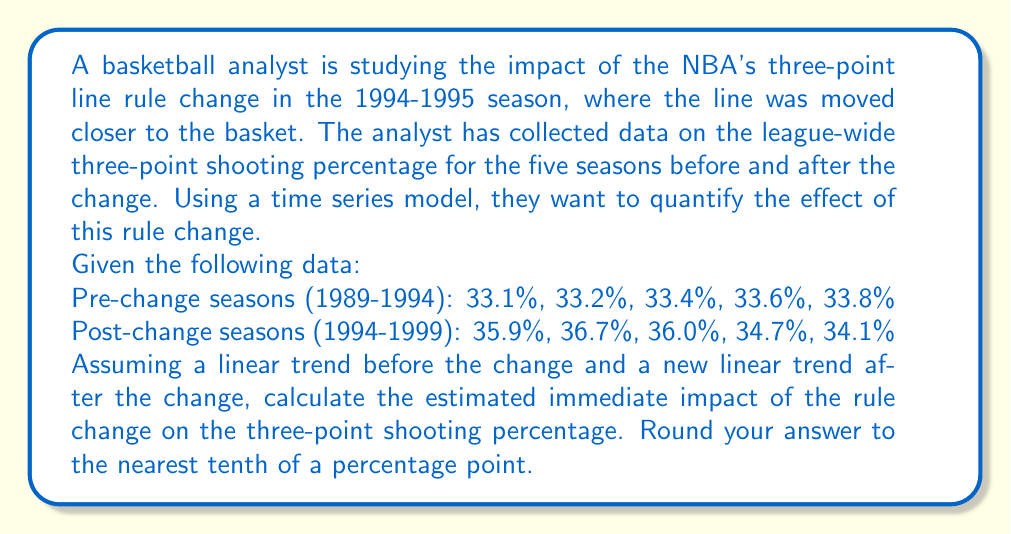Could you help me with this problem? To solve this problem, we'll use a segmented regression model, which is a type of time series analysis suitable for evaluating the impact of interventions or changes in trends.

Let's define our model as:

$$Y_t = \beta_0 + \beta_1T_t + \beta_2D_t + \beta_3(T_t - T_c)D_t + \epsilon_t$$

Where:
- $Y_t$ is the three-point shooting percentage
- $T_t$ is the time variable (seasons, coded as 1, 2, 3, ...)
- $D_t$ is a dummy variable (0 before the change, 1 after)
- $T_c$ is the time of the change (in this case, 6, as the change occurred after 5 seasons)
- $\beta_0$ is the intercept
- $\beta_1$ is the pre-change slope
- $\beta_2$ is the immediate change in level
- $\beta_3$ is the change in slope after the intervention

Step 1: Calculate the pre-change trend
Using the pre-change data, we can estimate the linear trend:
$$Y_t = 32.94 + 0.18T_t$$

Step 2: Extrapolate the pre-change trend to the post-change period
We can use this to predict what the percentages would have been without the change:
Season 6 (first post-change): 32.94 + 0.18 * 6 = 34.02%

Step 3: Calculate the difference between observed and predicted
The observed percentage for the first post-change season was 35.9%.
Difference: 35.9% - 34.02% = 1.88%

This difference represents the immediate impact of the rule change, which is our estimate of $\beta_2$ in the model.

Step 4: Round to the nearest tenth of a percentage point
1.88% rounds to 1.9%
Answer: The estimated immediate impact of the rule change on the three-point shooting percentage is 1.9 percentage points. 